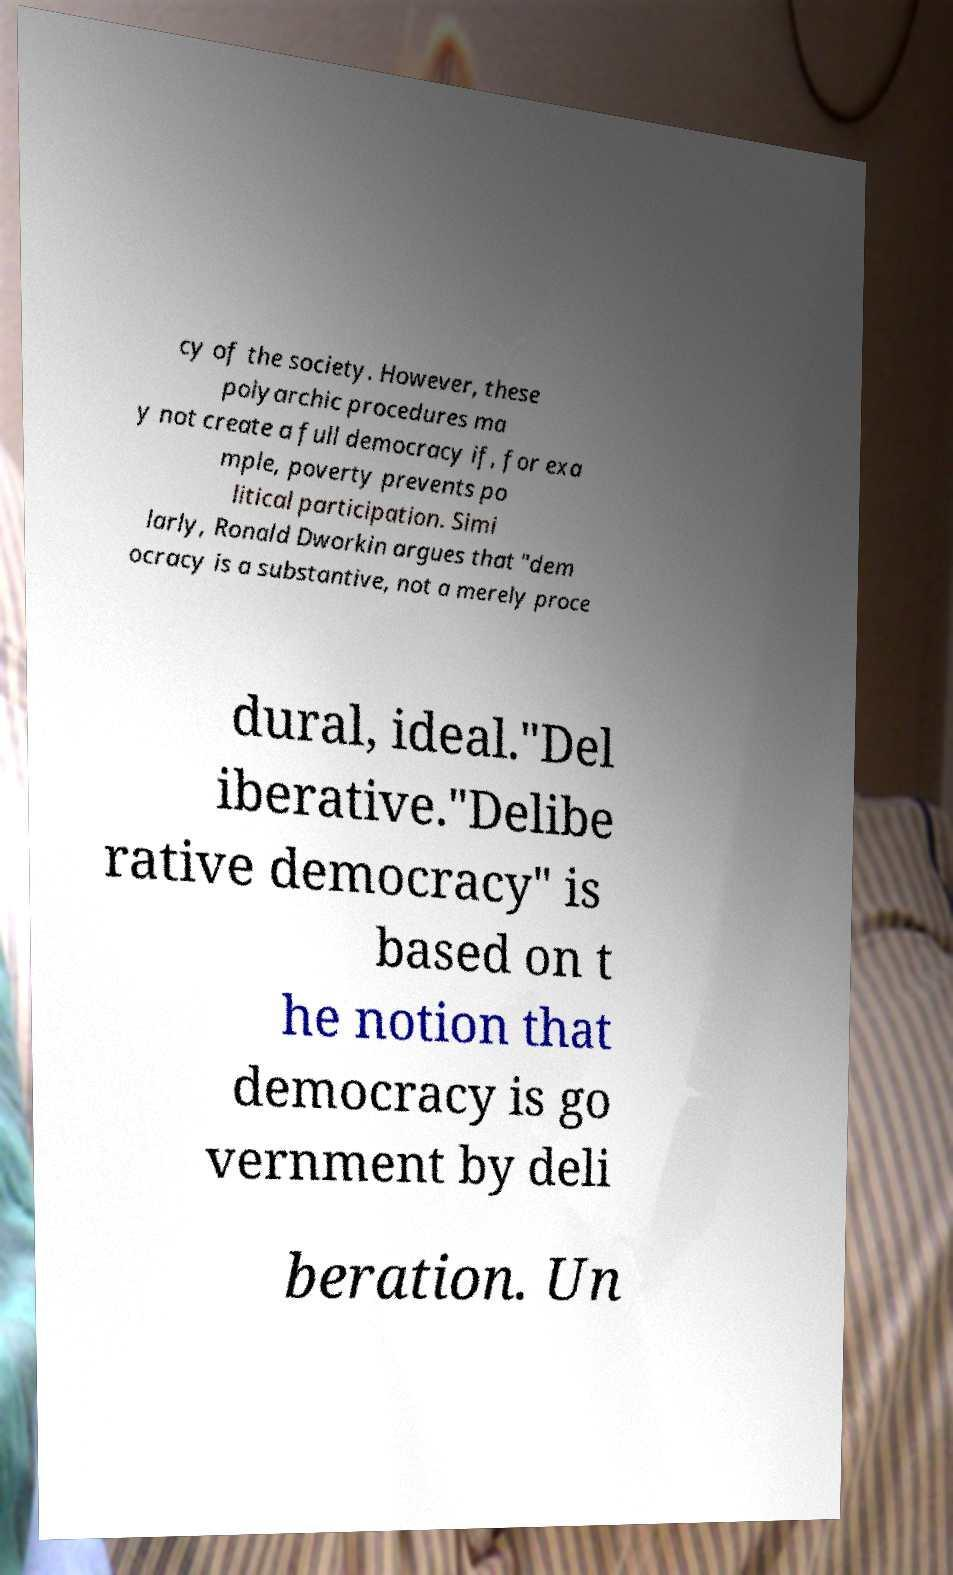Please identify and transcribe the text found in this image. cy of the society. However, these polyarchic procedures ma y not create a full democracy if, for exa mple, poverty prevents po litical participation. Simi larly, Ronald Dworkin argues that "dem ocracy is a substantive, not a merely proce dural, ideal."Del iberative."Delibe rative democracy" is based on t he notion that democracy is go vernment by deli beration. Un 